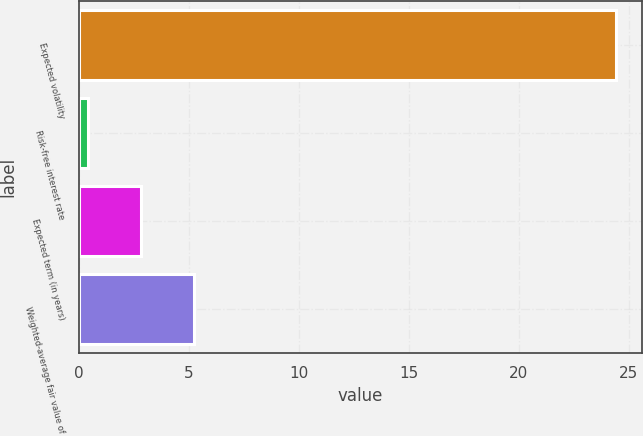Convert chart to OTSL. <chart><loc_0><loc_0><loc_500><loc_500><bar_chart><fcel>Expected volatility<fcel>Risk-free interest rate<fcel>Expected term (in years)<fcel>Weighted-average fair value of<nl><fcel>24.4<fcel>0.43<fcel>2.83<fcel>5.23<nl></chart> 